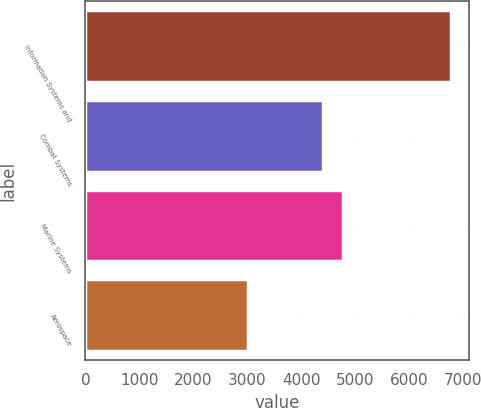<chart> <loc_0><loc_0><loc_500><loc_500><bar_chart><fcel>Information Systems and<fcel>Combat Systems<fcel>Marine Systems<fcel>Aerospace<nl><fcel>6781<fcel>4407<fcel>4783.9<fcel>3012<nl></chart> 